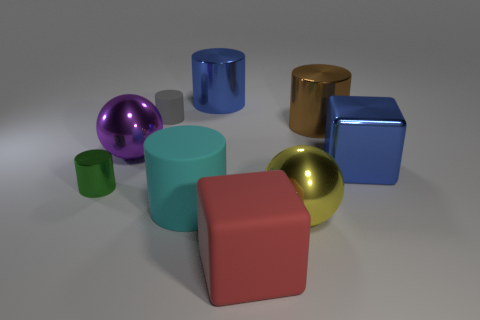Subtract all green metal cylinders. How many cylinders are left? 4 Subtract 2 cylinders. How many cylinders are left? 3 Subtract all brown cylinders. How many cylinders are left? 4 Subtract all cylinders. How many objects are left? 4 Subtract 0 brown cubes. How many objects are left? 9 Subtract all purple cylinders. Subtract all blue balls. How many cylinders are left? 5 Subtract all red things. Subtract all large purple objects. How many objects are left? 7 Add 1 small green shiny objects. How many small green shiny objects are left? 2 Add 2 big metal blocks. How many big metal blocks exist? 3 